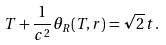<formula> <loc_0><loc_0><loc_500><loc_500>T + \frac { 1 } { c ^ { 2 } } \theta _ { R } ( T , { r } ) = \sqrt { 2 } \, t .</formula> 